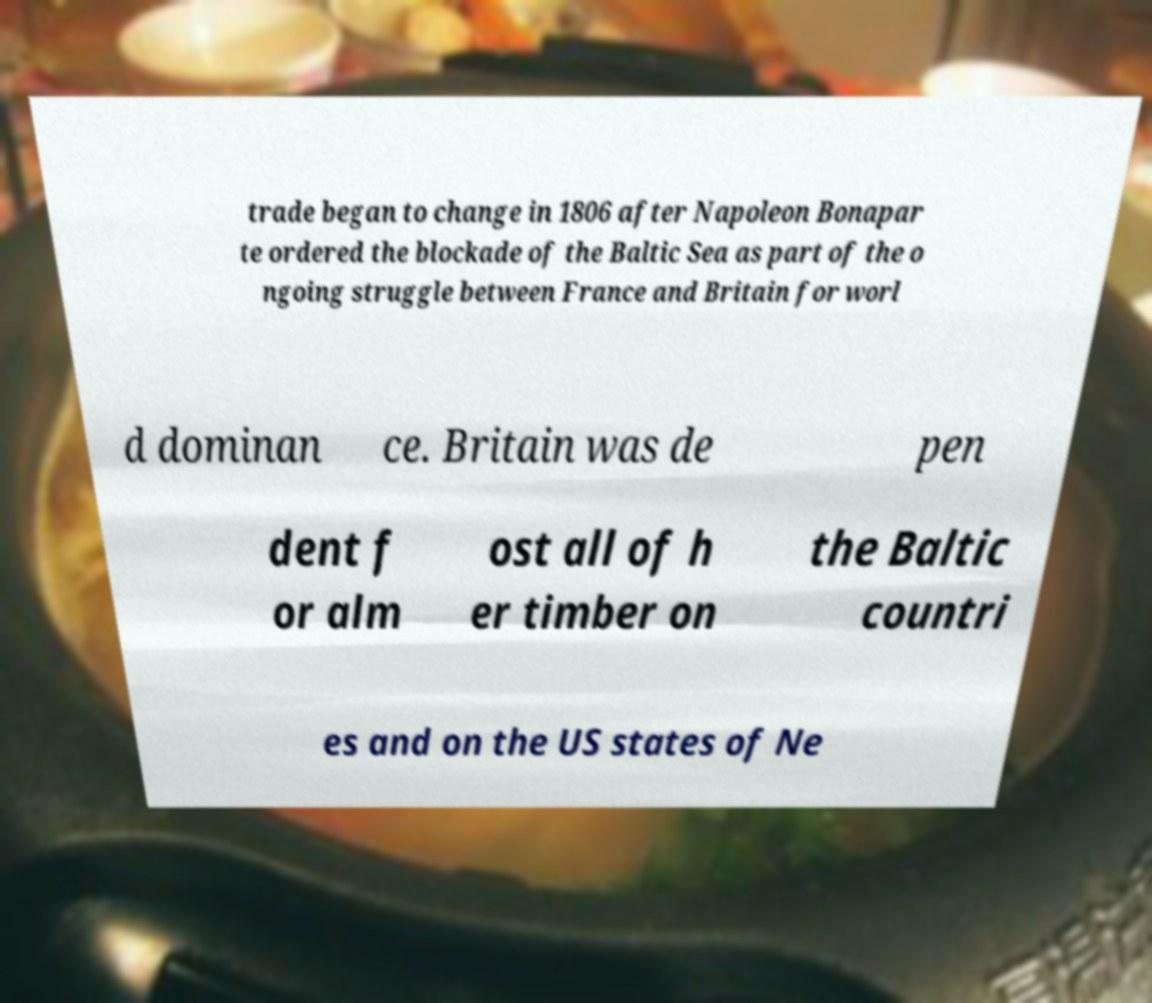Please read and relay the text visible in this image. What does it say? trade began to change in 1806 after Napoleon Bonapar te ordered the blockade of the Baltic Sea as part of the o ngoing struggle between France and Britain for worl d dominan ce. Britain was de pen dent f or alm ost all of h er timber on the Baltic countri es and on the US states of Ne 